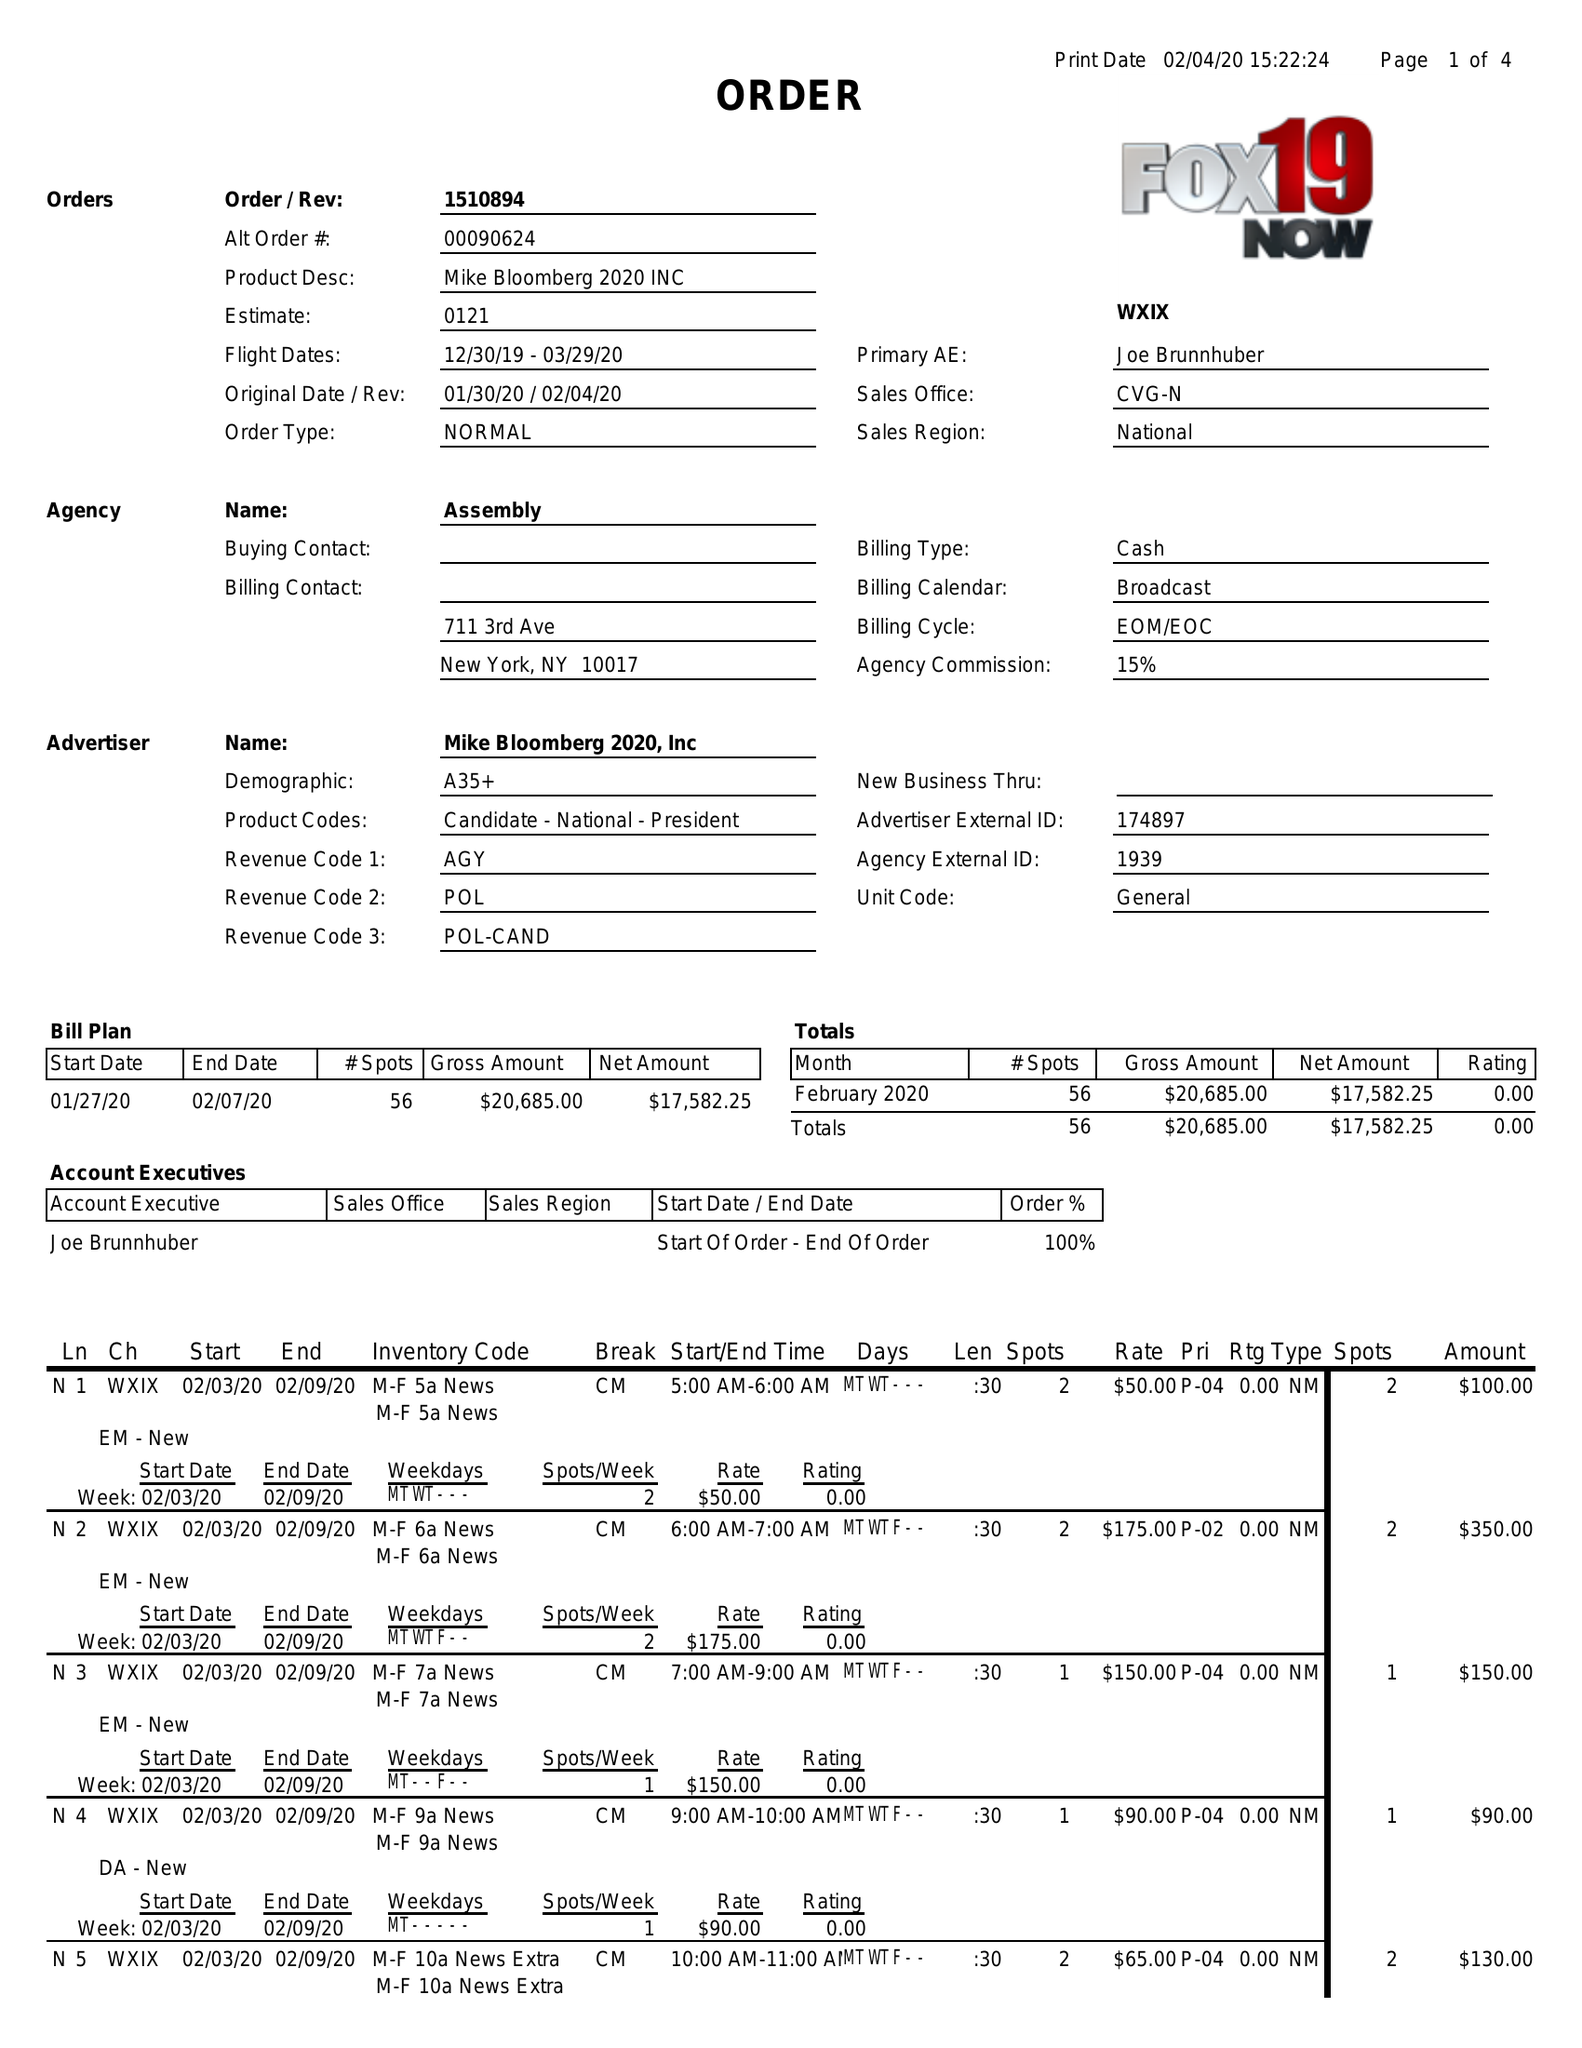What is the value for the advertiser?
Answer the question using a single word or phrase. MIKE BLOOMBERG 2020, INC 